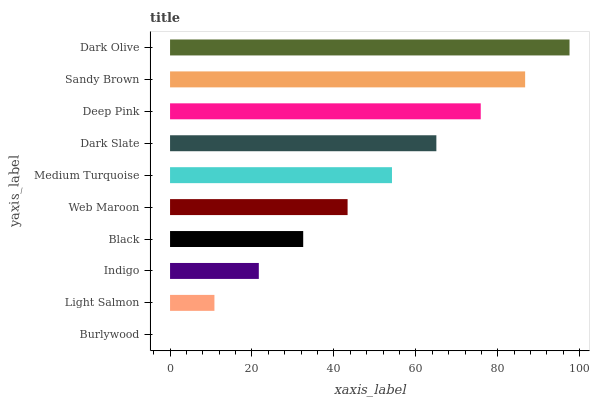Is Burlywood the minimum?
Answer yes or no. Yes. Is Dark Olive the maximum?
Answer yes or no. Yes. Is Light Salmon the minimum?
Answer yes or no. No. Is Light Salmon the maximum?
Answer yes or no. No. Is Light Salmon greater than Burlywood?
Answer yes or no. Yes. Is Burlywood less than Light Salmon?
Answer yes or no. Yes. Is Burlywood greater than Light Salmon?
Answer yes or no. No. Is Light Salmon less than Burlywood?
Answer yes or no. No. Is Medium Turquoise the high median?
Answer yes or no. Yes. Is Web Maroon the low median?
Answer yes or no. Yes. Is Dark Olive the high median?
Answer yes or no. No. Is Indigo the low median?
Answer yes or no. No. 